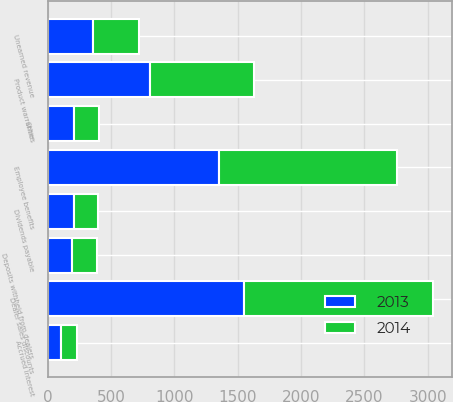Convert chart to OTSL. <chart><loc_0><loc_0><loc_500><loc_500><stacked_bar_chart><ecel><fcel>Dividends payable<fcel>Other<fcel>Dealer sales discounts<fcel>Employee benefits<fcel>Product warranties<fcel>Unearned revenue<fcel>Deposits withheld from dealers<fcel>Accrued interest<nl><fcel>2013<fcel>210<fcel>208<fcel>1551<fcel>1350<fcel>809<fcel>355<fcel>196<fcel>103<nl><fcel>2014<fcel>192<fcel>197<fcel>1491<fcel>1408<fcel>822<fcel>368<fcel>197<fcel>130<nl></chart> 